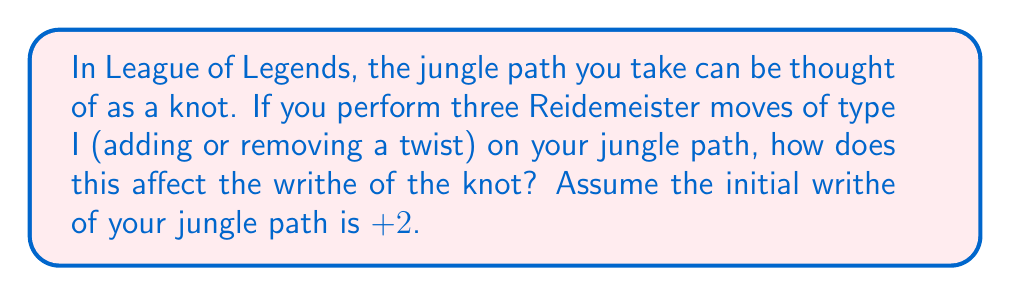Provide a solution to this math problem. Let's approach this step-by-step:

1) First, recall that the writhe is a knot invariant that measures the signed number of crossings in a knot diagram.

2) The Reidemeister move of type I adds or removes a twist in the knot. Each twist contributes +1 or -1 to the writhe, depending on its orientation.

3) The effect of a type I Reidemeister move on the writhe can be expressed mathematically as:

   $$\Delta w = \pm 1$$

   where $\Delta w$ is the change in writhe, and the sign depends on whether we're adding (+1) or removing (-1) a positive twist, or adding (-1) or removing (+1) a negative twist.

4) We're performing three type I moves, but we don't know if we're adding or removing twists, or what their orientations are. Let's consider the extreme cases:

   a) All three moves add positive twists: $\Delta w = +3$
   b) All three moves remove positive twists or add negative twists: $\Delta w = -3$

5) Therefore, the range of possible changes to the writhe is from -3 to +3.

6) Given that the initial writhe is +2, the final writhe could be anywhere in the range:

   $$2 + (-3) \leq \text{final writhe} \leq 2 + 3$$
   $$-1 \leq \text{final writhe} \leq 5$$

This means the final writhe could be any integer from -1 to 5, depending on the specific Reidemeister moves performed.
Answer: The final writhe could be any integer from -1 to 5. 